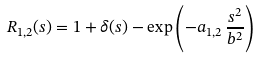Convert formula to latex. <formula><loc_0><loc_0><loc_500><loc_500>R _ { 1 , 2 } ( s ) = 1 + \delta ( s ) - \exp \left ( - a _ { 1 , 2 } \, \frac { s ^ { 2 } } { b ^ { 2 } } \right )</formula> 